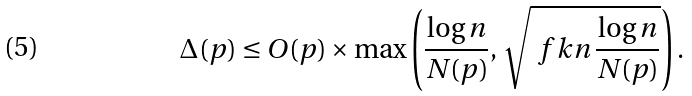Convert formula to latex. <formula><loc_0><loc_0><loc_500><loc_500>\Delta ( p ) \leq O ( p ) \times \max \left ( \frac { \log n } { N ( p ) } , \, \sqrt { \ f k n \, \frac { \log n } { N ( p ) } } \right ) .</formula> 